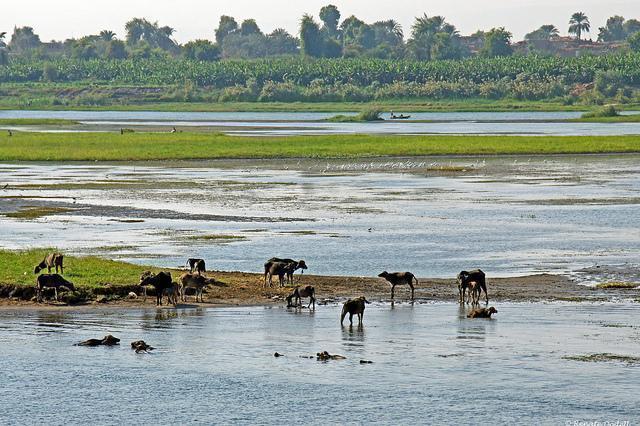What are the animals called?
Make your selection and explain in format: 'Answer: answer
Rationale: rationale.'
Options: Wildebeests, oxen, antelope, horses. Answer: wildebeests.
Rationale: They resemble cows. 